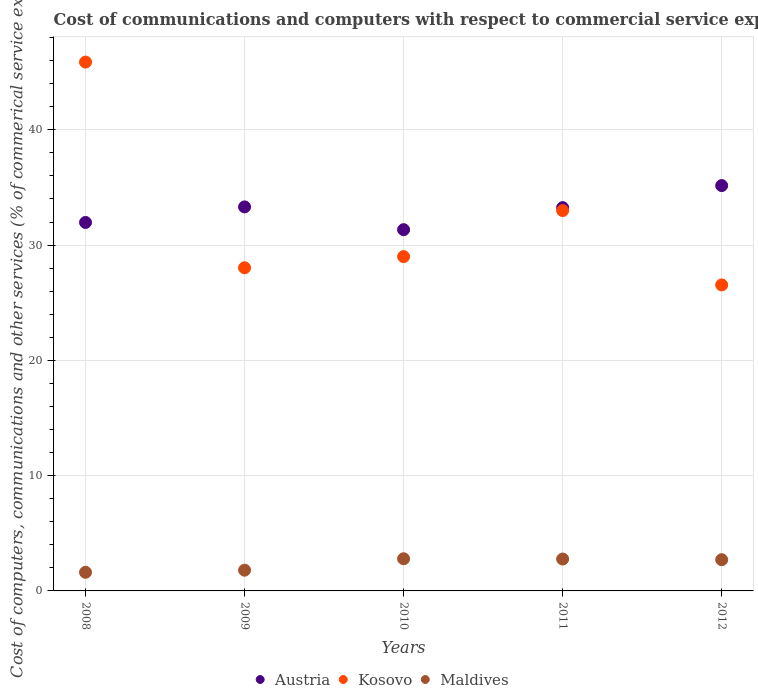How many different coloured dotlines are there?
Provide a short and direct response. 3. What is the cost of communications and computers in Kosovo in 2012?
Ensure brevity in your answer.  26.54. Across all years, what is the maximum cost of communications and computers in Maldives?
Provide a short and direct response. 2.79. Across all years, what is the minimum cost of communications and computers in Kosovo?
Keep it short and to the point. 26.54. In which year was the cost of communications and computers in Maldives maximum?
Offer a terse response. 2010. In which year was the cost of communications and computers in Maldives minimum?
Ensure brevity in your answer.  2008. What is the total cost of communications and computers in Austria in the graph?
Offer a terse response. 165.03. What is the difference between the cost of communications and computers in Austria in 2008 and that in 2010?
Your answer should be compact. 0.63. What is the difference between the cost of communications and computers in Maldives in 2011 and the cost of communications and computers in Austria in 2008?
Make the answer very short. -29.2. What is the average cost of communications and computers in Austria per year?
Your response must be concise. 33.01. In the year 2011, what is the difference between the cost of communications and computers in Maldives and cost of communications and computers in Austria?
Ensure brevity in your answer.  -30.48. What is the ratio of the cost of communications and computers in Austria in 2008 to that in 2012?
Provide a short and direct response. 0.91. Is the cost of communications and computers in Kosovo in 2010 less than that in 2011?
Ensure brevity in your answer.  Yes. Is the difference between the cost of communications and computers in Maldives in 2011 and 2012 greater than the difference between the cost of communications and computers in Austria in 2011 and 2012?
Your answer should be compact. Yes. What is the difference between the highest and the second highest cost of communications and computers in Austria?
Your answer should be very brief. 1.85. What is the difference between the highest and the lowest cost of communications and computers in Maldives?
Make the answer very short. 1.18. Is it the case that in every year, the sum of the cost of communications and computers in Austria and cost of communications and computers in Maldives  is greater than the cost of communications and computers in Kosovo?
Provide a short and direct response. No. Is the cost of communications and computers in Kosovo strictly less than the cost of communications and computers in Austria over the years?
Keep it short and to the point. No. How many dotlines are there?
Give a very brief answer. 3. How many years are there in the graph?
Your answer should be compact. 5. Does the graph contain any zero values?
Offer a very short reply. No. What is the title of the graph?
Ensure brevity in your answer.  Cost of communications and computers with respect to commercial service exports. Does "United Arab Emirates" appear as one of the legend labels in the graph?
Offer a terse response. No. What is the label or title of the X-axis?
Your answer should be compact. Years. What is the label or title of the Y-axis?
Make the answer very short. Cost of computers, communications and other services (% of commerical service exports). What is the Cost of computers, communications and other services (% of commerical service exports) of Austria in 2008?
Your answer should be very brief. 31.97. What is the Cost of computers, communications and other services (% of commerical service exports) of Kosovo in 2008?
Give a very brief answer. 45.88. What is the Cost of computers, communications and other services (% of commerical service exports) in Maldives in 2008?
Your answer should be compact. 1.61. What is the Cost of computers, communications and other services (% of commerical service exports) in Austria in 2009?
Make the answer very short. 33.31. What is the Cost of computers, communications and other services (% of commerical service exports) in Kosovo in 2009?
Offer a terse response. 28.03. What is the Cost of computers, communications and other services (% of commerical service exports) of Maldives in 2009?
Your answer should be very brief. 1.8. What is the Cost of computers, communications and other services (% of commerical service exports) in Austria in 2010?
Make the answer very short. 31.34. What is the Cost of computers, communications and other services (% of commerical service exports) in Kosovo in 2010?
Keep it short and to the point. 29. What is the Cost of computers, communications and other services (% of commerical service exports) in Maldives in 2010?
Offer a terse response. 2.79. What is the Cost of computers, communications and other services (% of commerical service exports) of Austria in 2011?
Make the answer very short. 33.25. What is the Cost of computers, communications and other services (% of commerical service exports) in Kosovo in 2011?
Offer a very short reply. 32.99. What is the Cost of computers, communications and other services (% of commerical service exports) in Maldives in 2011?
Your answer should be compact. 2.77. What is the Cost of computers, communications and other services (% of commerical service exports) of Austria in 2012?
Ensure brevity in your answer.  35.16. What is the Cost of computers, communications and other services (% of commerical service exports) of Kosovo in 2012?
Give a very brief answer. 26.54. What is the Cost of computers, communications and other services (% of commerical service exports) of Maldives in 2012?
Offer a very short reply. 2.71. Across all years, what is the maximum Cost of computers, communications and other services (% of commerical service exports) in Austria?
Your answer should be very brief. 35.16. Across all years, what is the maximum Cost of computers, communications and other services (% of commerical service exports) in Kosovo?
Keep it short and to the point. 45.88. Across all years, what is the maximum Cost of computers, communications and other services (% of commerical service exports) of Maldives?
Give a very brief answer. 2.79. Across all years, what is the minimum Cost of computers, communications and other services (% of commerical service exports) in Austria?
Keep it short and to the point. 31.34. Across all years, what is the minimum Cost of computers, communications and other services (% of commerical service exports) in Kosovo?
Keep it short and to the point. 26.54. Across all years, what is the minimum Cost of computers, communications and other services (% of commerical service exports) of Maldives?
Your answer should be compact. 1.61. What is the total Cost of computers, communications and other services (% of commerical service exports) of Austria in the graph?
Your response must be concise. 165.03. What is the total Cost of computers, communications and other services (% of commerical service exports) in Kosovo in the graph?
Give a very brief answer. 162.45. What is the total Cost of computers, communications and other services (% of commerical service exports) in Maldives in the graph?
Provide a succinct answer. 11.68. What is the difference between the Cost of computers, communications and other services (% of commerical service exports) of Austria in 2008 and that in 2009?
Your answer should be compact. -1.35. What is the difference between the Cost of computers, communications and other services (% of commerical service exports) of Kosovo in 2008 and that in 2009?
Provide a short and direct response. 17.84. What is the difference between the Cost of computers, communications and other services (% of commerical service exports) of Maldives in 2008 and that in 2009?
Provide a short and direct response. -0.19. What is the difference between the Cost of computers, communications and other services (% of commerical service exports) of Austria in 2008 and that in 2010?
Give a very brief answer. 0.63. What is the difference between the Cost of computers, communications and other services (% of commerical service exports) of Kosovo in 2008 and that in 2010?
Your answer should be compact. 16.87. What is the difference between the Cost of computers, communications and other services (% of commerical service exports) in Maldives in 2008 and that in 2010?
Your response must be concise. -1.18. What is the difference between the Cost of computers, communications and other services (% of commerical service exports) of Austria in 2008 and that in 2011?
Ensure brevity in your answer.  -1.28. What is the difference between the Cost of computers, communications and other services (% of commerical service exports) of Kosovo in 2008 and that in 2011?
Your answer should be compact. 12.88. What is the difference between the Cost of computers, communications and other services (% of commerical service exports) in Maldives in 2008 and that in 2011?
Offer a terse response. -1.15. What is the difference between the Cost of computers, communications and other services (% of commerical service exports) of Austria in 2008 and that in 2012?
Provide a succinct answer. -3.2. What is the difference between the Cost of computers, communications and other services (% of commerical service exports) in Kosovo in 2008 and that in 2012?
Provide a short and direct response. 19.33. What is the difference between the Cost of computers, communications and other services (% of commerical service exports) in Maldives in 2008 and that in 2012?
Your answer should be very brief. -1.09. What is the difference between the Cost of computers, communications and other services (% of commerical service exports) of Austria in 2009 and that in 2010?
Your answer should be compact. 1.98. What is the difference between the Cost of computers, communications and other services (% of commerical service exports) in Kosovo in 2009 and that in 2010?
Provide a short and direct response. -0.97. What is the difference between the Cost of computers, communications and other services (% of commerical service exports) of Maldives in 2009 and that in 2010?
Your answer should be very brief. -0.99. What is the difference between the Cost of computers, communications and other services (% of commerical service exports) of Austria in 2009 and that in 2011?
Ensure brevity in your answer.  0.06. What is the difference between the Cost of computers, communications and other services (% of commerical service exports) in Kosovo in 2009 and that in 2011?
Your response must be concise. -4.96. What is the difference between the Cost of computers, communications and other services (% of commerical service exports) of Maldives in 2009 and that in 2011?
Your response must be concise. -0.96. What is the difference between the Cost of computers, communications and other services (% of commerical service exports) in Austria in 2009 and that in 2012?
Keep it short and to the point. -1.85. What is the difference between the Cost of computers, communications and other services (% of commerical service exports) of Kosovo in 2009 and that in 2012?
Offer a very short reply. 1.49. What is the difference between the Cost of computers, communications and other services (% of commerical service exports) in Maldives in 2009 and that in 2012?
Offer a terse response. -0.91. What is the difference between the Cost of computers, communications and other services (% of commerical service exports) of Austria in 2010 and that in 2011?
Ensure brevity in your answer.  -1.91. What is the difference between the Cost of computers, communications and other services (% of commerical service exports) of Kosovo in 2010 and that in 2011?
Your answer should be compact. -3.99. What is the difference between the Cost of computers, communications and other services (% of commerical service exports) in Maldives in 2010 and that in 2011?
Provide a short and direct response. 0.03. What is the difference between the Cost of computers, communications and other services (% of commerical service exports) of Austria in 2010 and that in 2012?
Ensure brevity in your answer.  -3.83. What is the difference between the Cost of computers, communications and other services (% of commerical service exports) in Kosovo in 2010 and that in 2012?
Offer a very short reply. 2.46. What is the difference between the Cost of computers, communications and other services (% of commerical service exports) of Maldives in 2010 and that in 2012?
Offer a terse response. 0.08. What is the difference between the Cost of computers, communications and other services (% of commerical service exports) of Austria in 2011 and that in 2012?
Your response must be concise. -1.91. What is the difference between the Cost of computers, communications and other services (% of commerical service exports) in Kosovo in 2011 and that in 2012?
Give a very brief answer. 6.45. What is the difference between the Cost of computers, communications and other services (% of commerical service exports) of Maldives in 2011 and that in 2012?
Ensure brevity in your answer.  0.06. What is the difference between the Cost of computers, communications and other services (% of commerical service exports) of Austria in 2008 and the Cost of computers, communications and other services (% of commerical service exports) of Kosovo in 2009?
Your answer should be compact. 3.93. What is the difference between the Cost of computers, communications and other services (% of commerical service exports) of Austria in 2008 and the Cost of computers, communications and other services (% of commerical service exports) of Maldives in 2009?
Keep it short and to the point. 30.16. What is the difference between the Cost of computers, communications and other services (% of commerical service exports) in Kosovo in 2008 and the Cost of computers, communications and other services (% of commerical service exports) in Maldives in 2009?
Make the answer very short. 44.08. What is the difference between the Cost of computers, communications and other services (% of commerical service exports) of Austria in 2008 and the Cost of computers, communications and other services (% of commerical service exports) of Kosovo in 2010?
Offer a very short reply. 2.96. What is the difference between the Cost of computers, communications and other services (% of commerical service exports) in Austria in 2008 and the Cost of computers, communications and other services (% of commerical service exports) in Maldives in 2010?
Your answer should be compact. 29.18. What is the difference between the Cost of computers, communications and other services (% of commerical service exports) of Kosovo in 2008 and the Cost of computers, communications and other services (% of commerical service exports) of Maldives in 2010?
Your answer should be compact. 43.09. What is the difference between the Cost of computers, communications and other services (% of commerical service exports) in Austria in 2008 and the Cost of computers, communications and other services (% of commerical service exports) in Kosovo in 2011?
Ensure brevity in your answer.  -1.03. What is the difference between the Cost of computers, communications and other services (% of commerical service exports) in Austria in 2008 and the Cost of computers, communications and other services (% of commerical service exports) in Maldives in 2011?
Your answer should be very brief. 29.2. What is the difference between the Cost of computers, communications and other services (% of commerical service exports) of Kosovo in 2008 and the Cost of computers, communications and other services (% of commerical service exports) of Maldives in 2011?
Offer a very short reply. 43.11. What is the difference between the Cost of computers, communications and other services (% of commerical service exports) of Austria in 2008 and the Cost of computers, communications and other services (% of commerical service exports) of Kosovo in 2012?
Offer a very short reply. 5.42. What is the difference between the Cost of computers, communications and other services (% of commerical service exports) in Austria in 2008 and the Cost of computers, communications and other services (% of commerical service exports) in Maldives in 2012?
Keep it short and to the point. 29.26. What is the difference between the Cost of computers, communications and other services (% of commerical service exports) of Kosovo in 2008 and the Cost of computers, communications and other services (% of commerical service exports) of Maldives in 2012?
Your answer should be compact. 43.17. What is the difference between the Cost of computers, communications and other services (% of commerical service exports) in Austria in 2009 and the Cost of computers, communications and other services (% of commerical service exports) in Kosovo in 2010?
Keep it short and to the point. 4.31. What is the difference between the Cost of computers, communications and other services (% of commerical service exports) of Austria in 2009 and the Cost of computers, communications and other services (% of commerical service exports) of Maldives in 2010?
Provide a short and direct response. 30.52. What is the difference between the Cost of computers, communications and other services (% of commerical service exports) of Kosovo in 2009 and the Cost of computers, communications and other services (% of commerical service exports) of Maldives in 2010?
Give a very brief answer. 25.24. What is the difference between the Cost of computers, communications and other services (% of commerical service exports) in Austria in 2009 and the Cost of computers, communications and other services (% of commerical service exports) in Kosovo in 2011?
Offer a terse response. 0.32. What is the difference between the Cost of computers, communications and other services (% of commerical service exports) in Austria in 2009 and the Cost of computers, communications and other services (% of commerical service exports) in Maldives in 2011?
Ensure brevity in your answer.  30.55. What is the difference between the Cost of computers, communications and other services (% of commerical service exports) in Kosovo in 2009 and the Cost of computers, communications and other services (% of commerical service exports) in Maldives in 2011?
Offer a terse response. 25.27. What is the difference between the Cost of computers, communications and other services (% of commerical service exports) in Austria in 2009 and the Cost of computers, communications and other services (% of commerical service exports) in Kosovo in 2012?
Your response must be concise. 6.77. What is the difference between the Cost of computers, communications and other services (% of commerical service exports) in Austria in 2009 and the Cost of computers, communications and other services (% of commerical service exports) in Maldives in 2012?
Your answer should be very brief. 30.61. What is the difference between the Cost of computers, communications and other services (% of commerical service exports) in Kosovo in 2009 and the Cost of computers, communications and other services (% of commerical service exports) in Maldives in 2012?
Your answer should be very brief. 25.32. What is the difference between the Cost of computers, communications and other services (% of commerical service exports) in Austria in 2010 and the Cost of computers, communications and other services (% of commerical service exports) in Kosovo in 2011?
Provide a short and direct response. -1.66. What is the difference between the Cost of computers, communications and other services (% of commerical service exports) of Austria in 2010 and the Cost of computers, communications and other services (% of commerical service exports) of Maldives in 2011?
Your response must be concise. 28.57. What is the difference between the Cost of computers, communications and other services (% of commerical service exports) of Kosovo in 2010 and the Cost of computers, communications and other services (% of commerical service exports) of Maldives in 2011?
Your answer should be compact. 26.24. What is the difference between the Cost of computers, communications and other services (% of commerical service exports) of Austria in 2010 and the Cost of computers, communications and other services (% of commerical service exports) of Kosovo in 2012?
Your answer should be very brief. 4.79. What is the difference between the Cost of computers, communications and other services (% of commerical service exports) of Austria in 2010 and the Cost of computers, communications and other services (% of commerical service exports) of Maldives in 2012?
Ensure brevity in your answer.  28.63. What is the difference between the Cost of computers, communications and other services (% of commerical service exports) of Kosovo in 2010 and the Cost of computers, communications and other services (% of commerical service exports) of Maldives in 2012?
Keep it short and to the point. 26.29. What is the difference between the Cost of computers, communications and other services (% of commerical service exports) of Austria in 2011 and the Cost of computers, communications and other services (% of commerical service exports) of Kosovo in 2012?
Your response must be concise. 6.71. What is the difference between the Cost of computers, communications and other services (% of commerical service exports) in Austria in 2011 and the Cost of computers, communications and other services (% of commerical service exports) in Maldives in 2012?
Give a very brief answer. 30.54. What is the difference between the Cost of computers, communications and other services (% of commerical service exports) of Kosovo in 2011 and the Cost of computers, communications and other services (% of commerical service exports) of Maldives in 2012?
Your answer should be very brief. 30.29. What is the average Cost of computers, communications and other services (% of commerical service exports) in Austria per year?
Your answer should be compact. 33.01. What is the average Cost of computers, communications and other services (% of commerical service exports) of Kosovo per year?
Provide a succinct answer. 32.49. What is the average Cost of computers, communications and other services (% of commerical service exports) in Maldives per year?
Provide a succinct answer. 2.34. In the year 2008, what is the difference between the Cost of computers, communications and other services (% of commerical service exports) of Austria and Cost of computers, communications and other services (% of commerical service exports) of Kosovo?
Your answer should be compact. -13.91. In the year 2008, what is the difference between the Cost of computers, communications and other services (% of commerical service exports) of Austria and Cost of computers, communications and other services (% of commerical service exports) of Maldives?
Provide a short and direct response. 30.35. In the year 2008, what is the difference between the Cost of computers, communications and other services (% of commerical service exports) of Kosovo and Cost of computers, communications and other services (% of commerical service exports) of Maldives?
Your answer should be compact. 44.26. In the year 2009, what is the difference between the Cost of computers, communications and other services (% of commerical service exports) in Austria and Cost of computers, communications and other services (% of commerical service exports) in Kosovo?
Provide a short and direct response. 5.28. In the year 2009, what is the difference between the Cost of computers, communications and other services (% of commerical service exports) of Austria and Cost of computers, communications and other services (% of commerical service exports) of Maldives?
Ensure brevity in your answer.  31.51. In the year 2009, what is the difference between the Cost of computers, communications and other services (% of commerical service exports) in Kosovo and Cost of computers, communications and other services (% of commerical service exports) in Maldives?
Your response must be concise. 26.23. In the year 2010, what is the difference between the Cost of computers, communications and other services (% of commerical service exports) in Austria and Cost of computers, communications and other services (% of commerical service exports) in Kosovo?
Offer a terse response. 2.34. In the year 2010, what is the difference between the Cost of computers, communications and other services (% of commerical service exports) of Austria and Cost of computers, communications and other services (% of commerical service exports) of Maldives?
Your response must be concise. 28.55. In the year 2010, what is the difference between the Cost of computers, communications and other services (% of commerical service exports) of Kosovo and Cost of computers, communications and other services (% of commerical service exports) of Maldives?
Make the answer very short. 26.21. In the year 2011, what is the difference between the Cost of computers, communications and other services (% of commerical service exports) of Austria and Cost of computers, communications and other services (% of commerical service exports) of Kosovo?
Provide a succinct answer. 0.26. In the year 2011, what is the difference between the Cost of computers, communications and other services (% of commerical service exports) in Austria and Cost of computers, communications and other services (% of commerical service exports) in Maldives?
Keep it short and to the point. 30.48. In the year 2011, what is the difference between the Cost of computers, communications and other services (% of commerical service exports) of Kosovo and Cost of computers, communications and other services (% of commerical service exports) of Maldives?
Make the answer very short. 30.23. In the year 2012, what is the difference between the Cost of computers, communications and other services (% of commerical service exports) of Austria and Cost of computers, communications and other services (% of commerical service exports) of Kosovo?
Offer a terse response. 8.62. In the year 2012, what is the difference between the Cost of computers, communications and other services (% of commerical service exports) of Austria and Cost of computers, communications and other services (% of commerical service exports) of Maldives?
Your answer should be compact. 32.46. In the year 2012, what is the difference between the Cost of computers, communications and other services (% of commerical service exports) of Kosovo and Cost of computers, communications and other services (% of commerical service exports) of Maldives?
Keep it short and to the point. 23.84. What is the ratio of the Cost of computers, communications and other services (% of commerical service exports) of Austria in 2008 to that in 2009?
Your answer should be very brief. 0.96. What is the ratio of the Cost of computers, communications and other services (% of commerical service exports) in Kosovo in 2008 to that in 2009?
Your answer should be very brief. 1.64. What is the ratio of the Cost of computers, communications and other services (% of commerical service exports) of Maldives in 2008 to that in 2009?
Ensure brevity in your answer.  0.9. What is the ratio of the Cost of computers, communications and other services (% of commerical service exports) in Kosovo in 2008 to that in 2010?
Your answer should be compact. 1.58. What is the ratio of the Cost of computers, communications and other services (% of commerical service exports) of Maldives in 2008 to that in 2010?
Give a very brief answer. 0.58. What is the ratio of the Cost of computers, communications and other services (% of commerical service exports) of Austria in 2008 to that in 2011?
Your answer should be very brief. 0.96. What is the ratio of the Cost of computers, communications and other services (% of commerical service exports) in Kosovo in 2008 to that in 2011?
Give a very brief answer. 1.39. What is the ratio of the Cost of computers, communications and other services (% of commerical service exports) in Maldives in 2008 to that in 2011?
Make the answer very short. 0.58. What is the ratio of the Cost of computers, communications and other services (% of commerical service exports) of Austria in 2008 to that in 2012?
Ensure brevity in your answer.  0.91. What is the ratio of the Cost of computers, communications and other services (% of commerical service exports) of Kosovo in 2008 to that in 2012?
Your response must be concise. 1.73. What is the ratio of the Cost of computers, communications and other services (% of commerical service exports) of Maldives in 2008 to that in 2012?
Offer a very short reply. 0.6. What is the ratio of the Cost of computers, communications and other services (% of commerical service exports) of Austria in 2009 to that in 2010?
Give a very brief answer. 1.06. What is the ratio of the Cost of computers, communications and other services (% of commerical service exports) in Kosovo in 2009 to that in 2010?
Your answer should be compact. 0.97. What is the ratio of the Cost of computers, communications and other services (% of commerical service exports) in Maldives in 2009 to that in 2010?
Your answer should be compact. 0.65. What is the ratio of the Cost of computers, communications and other services (% of commerical service exports) of Austria in 2009 to that in 2011?
Your answer should be compact. 1. What is the ratio of the Cost of computers, communications and other services (% of commerical service exports) in Kosovo in 2009 to that in 2011?
Your response must be concise. 0.85. What is the ratio of the Cost of computers, communications and other services (% of commerical service exports) of Maldives in 2009 to that in 2011?
Your response must be concise. 0.65. What is the ratio of the Cost of computers, communications and other services (% of commerical service exports) in Austria in 2009 to that in 2012?
Keep it short and to the point. 0.95. What is the ratio of the Cost of computers, communications and other services (% of commerical service exports) of Kosovo in 2009 to that in 2012?
Make the answer very short. 1.06. What is the ratio of the Cost of computers, communications and other services (% of commerical service exports) in Maldives in 2009 to that in 2012?
Your answer should be very brief. 0.66. What is the ratio of the Cost of computers, communications and other services (% of commerical service exports) of Austria in 2010 to that in 2011?
Offer a terse response. 0.94. What is the ratio of the Cost of computers, communications and other services (% of commerical service exports) in Kosovo in 2010 to that in 2011?
Provide a succinct answer. 0.88. What is the ratio of the Cost of computers, communications and other services (% of commerical service exports) in Austria in 2010 to that in 2012?
Give a very brief answer. 0.89. What is the ratio of the Cost of computers, communications and other services (% of commerical service exports) in Kosovo in 2010 to that in 2012?
Keep it short and to the point. 1.09. What is the ratio of the Cost of computers, communications and other services (% of commerical service exports) in Austria in 2011 to that in 2012?
Your answer should be compact. 0.95. What is the ratio of the Cost of computers, communications and other services (% of commerical service exports) of Kosovo in 2011 to that in 2012?
Make the answer very short. 1.24. What is the ratio of the Cost of computers, communications and other services (% of commerical service exports) in Maldives in 2011 to that in 2012?
Give a very brief answer. 1.02. What is the difference between the highest and the second highest Cost of computers, communications and other services (% of commerical service exports) in Austria?
Provide a succinct answer. 1.85. What is the difference between the highest and the second highest Cost of computers, communications and other services (% of commerical service exports) of Kosovo?
Your answer should be very brief. 12.88. What is the difference between the highest and the second highest Cost of computers, communications and other services (% of commerical service exports) in Maldives?
Make the answer very short. 0.03. What is the difference between the highest and the lowest Cost of computers, communications and other services (% of commerical service exports) in Austria?
Your answer should be compact. 3.83. What is the difference between the highest and the lowest Cost of computers, communications and other services (% of commerical service exports) in Kosovo?
Ensure brevity in your answer.  19.33. What is the difference between the highest and the lowest Cost of computers, communications and other services (% of commerical service exports) in Maldives?
Your answer should be very brief. 1.18. 